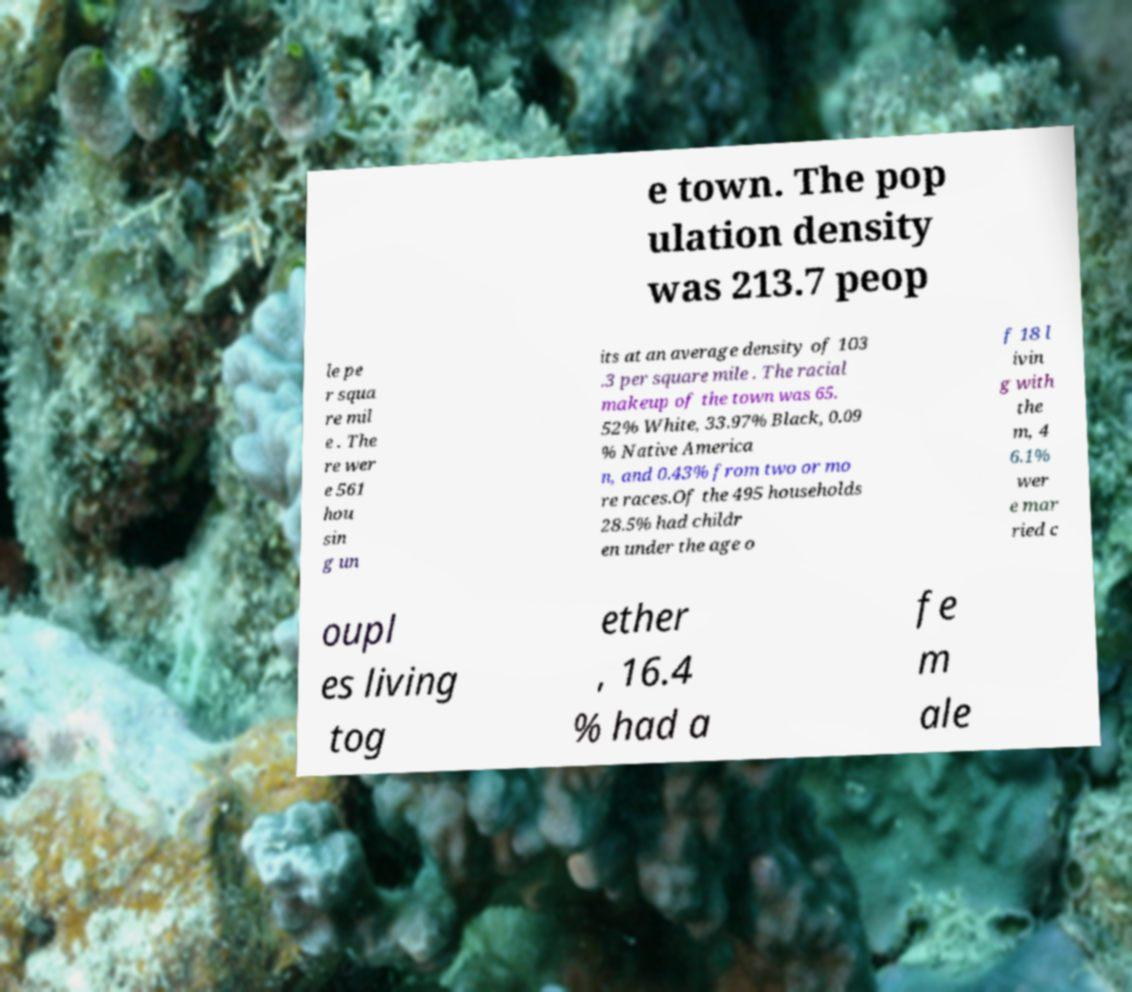Could you extract and type out the text from this image? e town. The pop ulation density was 213.7 peop le pe r squa re mil e . The re wer e 561 hou sin g un its at an average density of 103 .3 per square mile . The racial makeup of the town was 65. 52% White, 33.97% Black, 0.09 % Native America n, and 0.43% from two or mo re races.Of the 495 households 28.5% had childr en under the age o f 18 l ivin g with the m, 4 6.1% wer e mar ried c oupl es living tog ether , 16.4 % had a fe m ale 